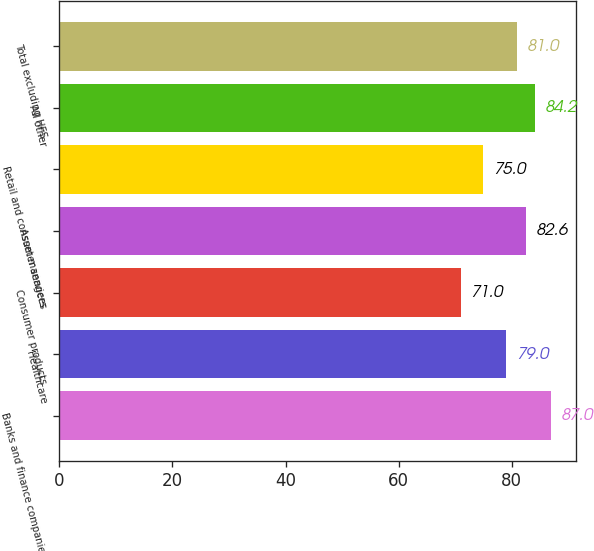<chart> <loc_0><loc_0><loc_500><loc_500><bar_chart><fcel>Banks and finance companies<fcel>Healthcare<fcel>Consumer products<fcel>Asset managers<fcel>Retail and consumer services<fcel>All other<fcel>Total excluding HFS<nl><fcel>87<fcel>79<fcel>71<fcel>82.6<fcel>75<fcel>84.2<fcel>81<nl></chart> 